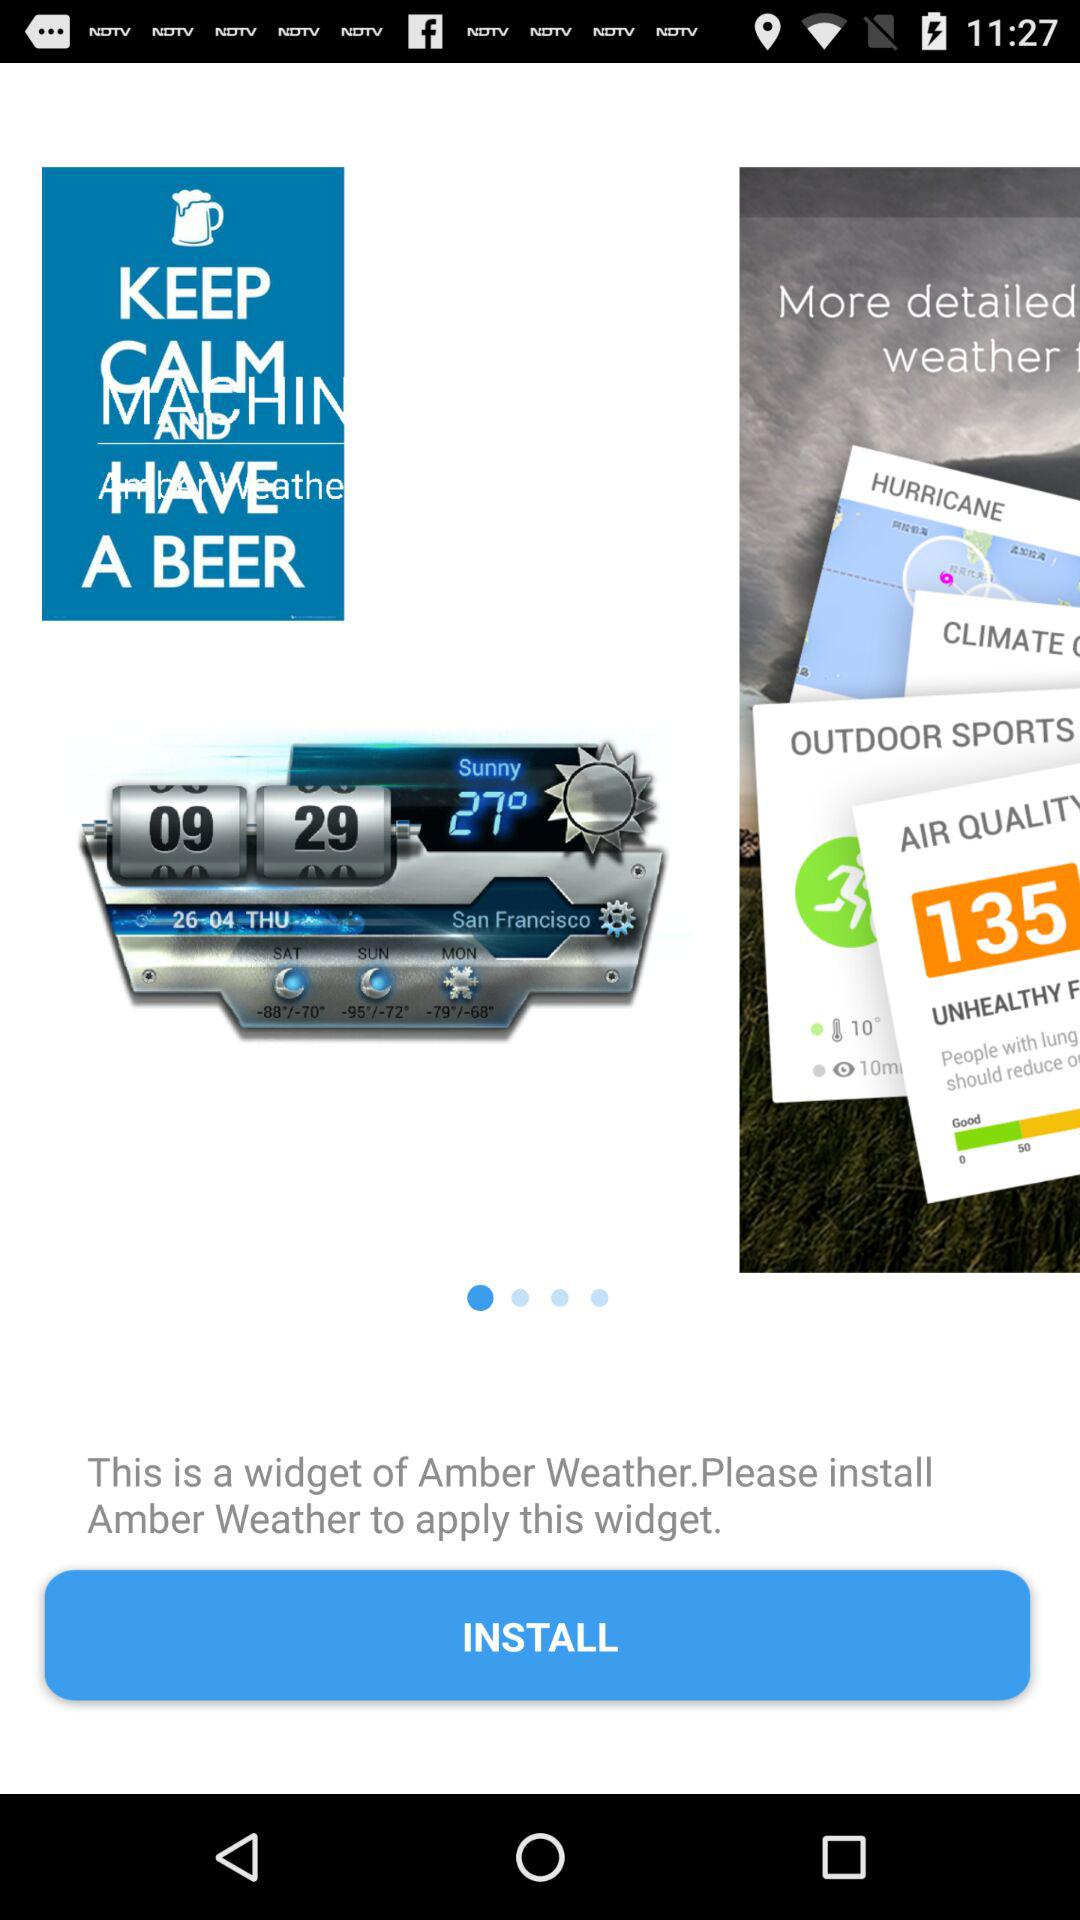What is the day on April 26? The day is Thursday. 